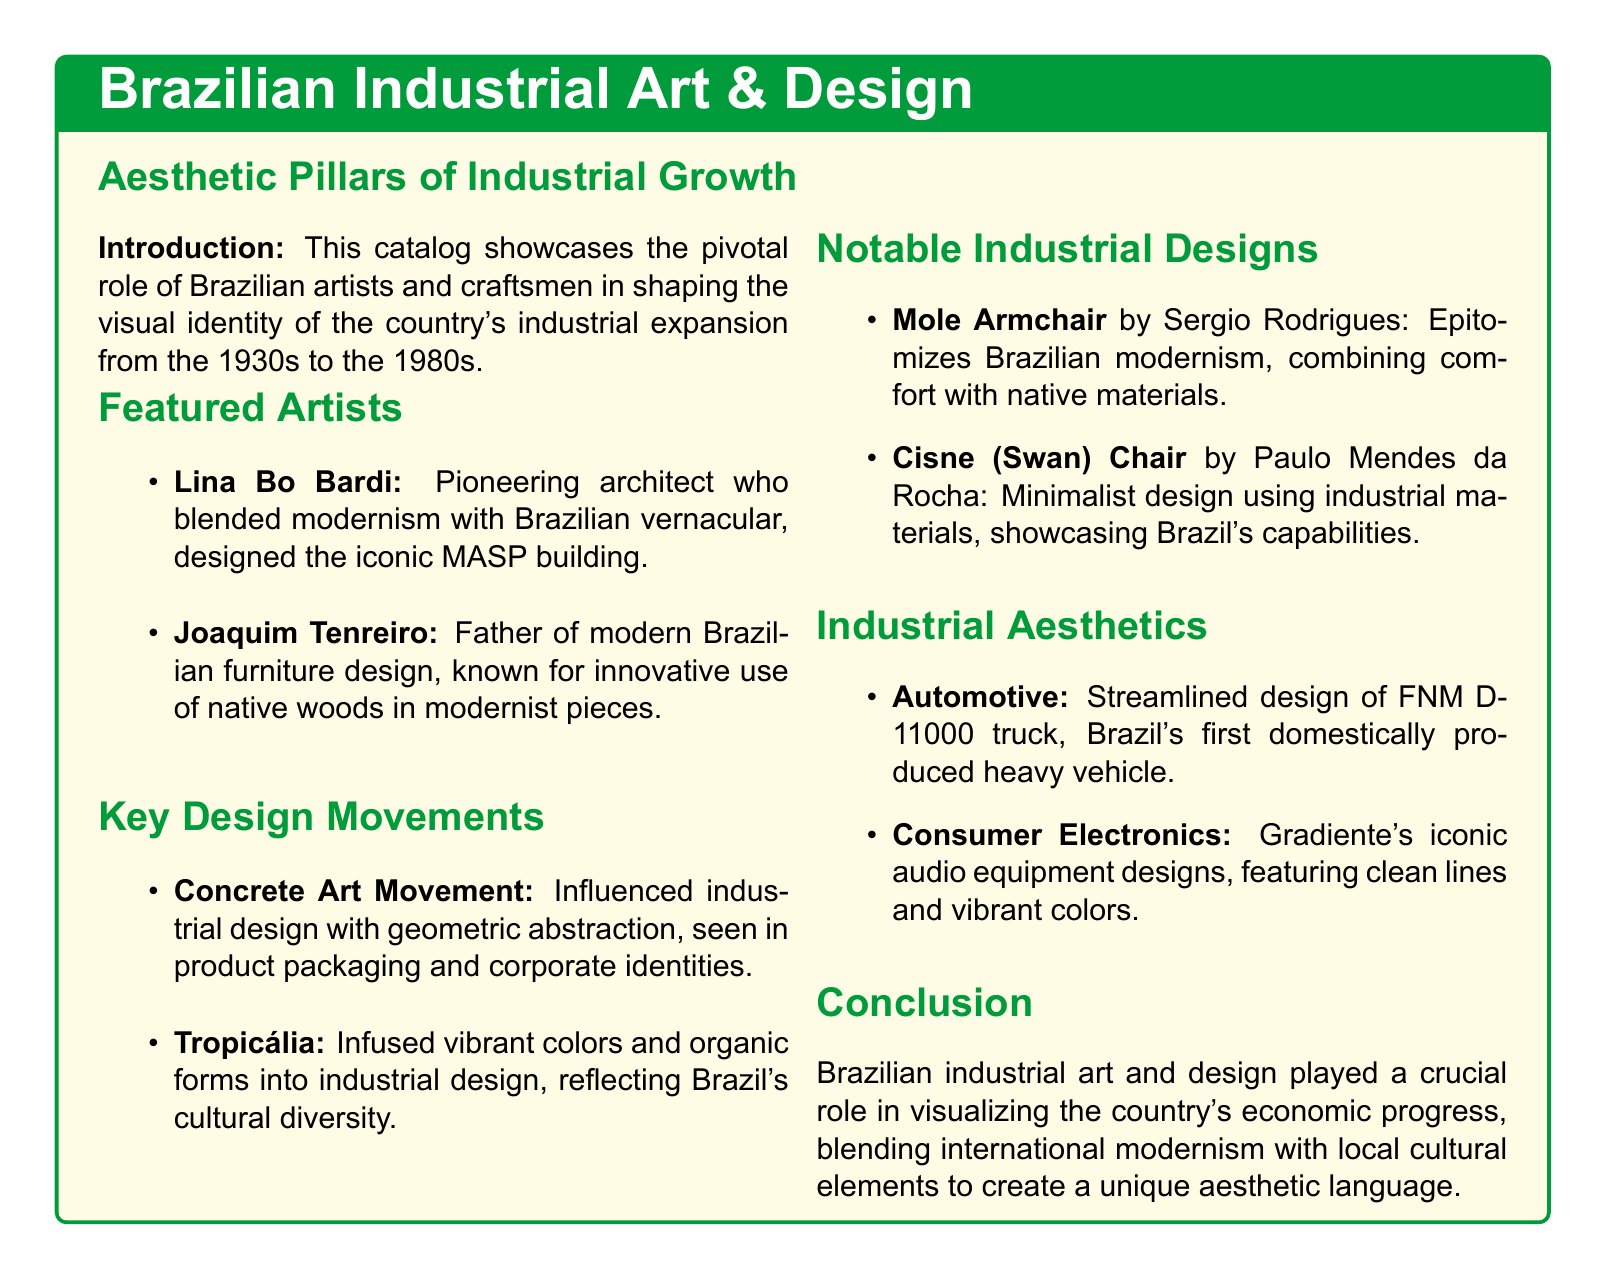What is the time period explored in the catalog? The catalog focuses on the industrial expansion in Brazil from the 1930s to the 1980s.
Answer: 1930s to the 1980s Who is known as the father of modern Brazilian furniture design? The document mentions Joaquim Tenreiro for his contributions to modern furniture design in Brazil.
Answer: Joaquim Tenreiro Which building did Lina Bo Bardi design? The catalog highlights the MASP building as a significant work by Lina Bo Bardi.
Answer: MASP building What design movement influenced product packaging in Brazil? The Concrete Art Movement is noted for its impact on industrial design, including product packaging.
Answer: Concrete Art Movement What notable chair did Sergio Rodrigues design? The catalog specifically mentions the Mole Armchair as a key piece designed by Sergio Rodrigues.
Answer: Mole Armchair What aesthetic is reflected in Gradiente's audio equipment designs? The document describes Gradiente's designs as featuring clean lines and vibrant colors.
Answer: Clean lines and vibrant colors Which chair is associated with Paulo Mendes da Rocha? The Cisne (Swan) Chair is mentioned as a notable design associated with Paulo Mendes da Rocha.
Answer: Cisne (Swan) Chair What vehicle is highlighted as Brazil's first domestically produced heavy vehicle? The FNM D-11000 truck is noted in the catalog for being the first of its kind.
Answer: FNM D-11000 truck Which cultural elements are reflected in the Tropicália movement? The document states that Tropicália incorporated vibrant colors and organic forms into industrial design.
Answer: Vibrant colors and organic forms 